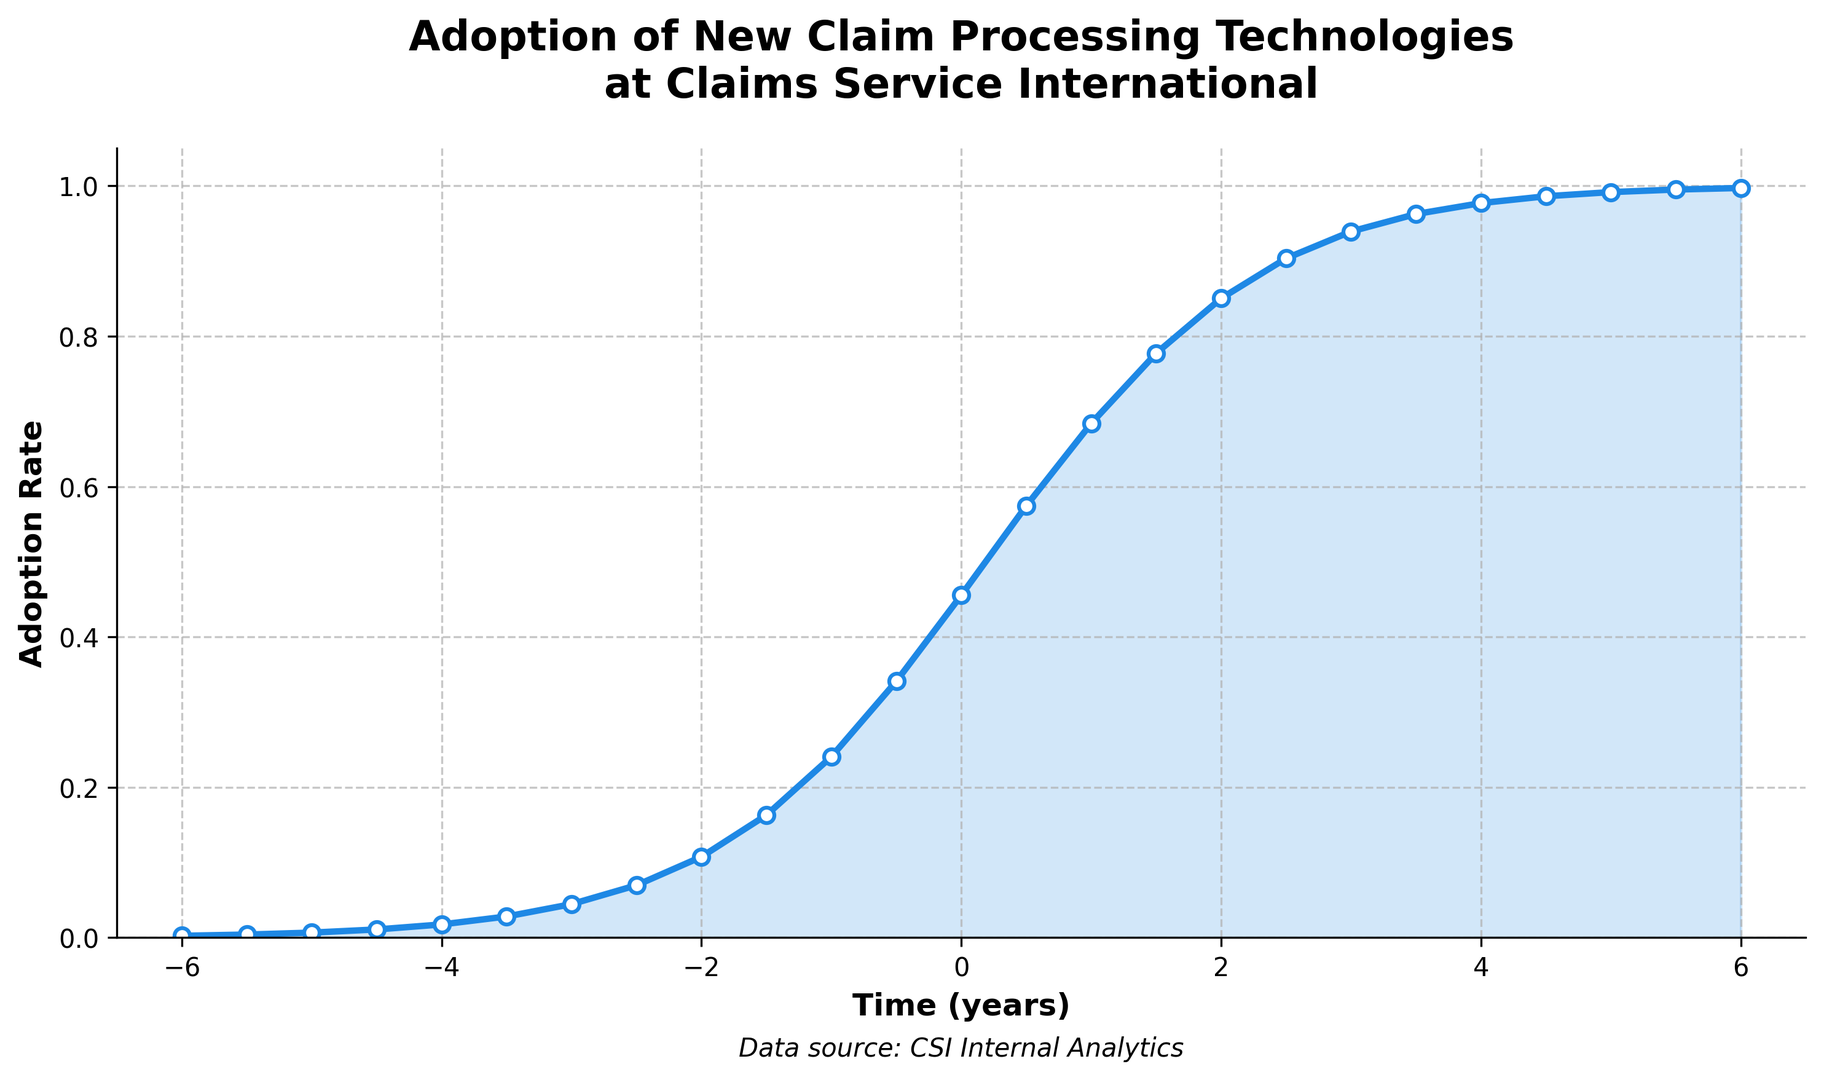When does the adoption rate reach 50%? The adoption rate reaches 50% when the y-value is closest to 0.5. According to the data, this occurs approximately at x = 0.
Answer: 0 What is the adoption rate at time -3 years? To find the adoption rate at time -3 years, locate the value of y corresponding to x = -3 in the data. It is approximately y = 0.044565.
Answer: 0.044565 What is the difference in adoption rates between time -2 years and 2 years? To find the difference, look up the y-values for x = -2 and x = 2. The values are 0.107585 and 0.850457, respectively. Subtract the smaller value from the larger value: 0.850457 - 0.107585 = 0.742872.
Answer: 0.742872 At which time does the adoption rate first exceed 90%? To determine when the adoption rate first exceeds 90%, find the smallest x-value for which y is greater than 0.9. According to the data, this occurs at x = 2.5.
Answer: 2.5 Which time period shows the fastest increase in adoption rate? To find the fastest increase, identify the steepest slope in the y-values over the x values. The rise is fastest between x = -1.5 and x = 0.5, where the adoption rate goes from approximately 0.163058 to 0.574442.
Answer: Between -1.5 and 0.5 What is the general shape of the adoption curve? By examining the plot, it’s clear the adoption curve has an S-shape, typical of a Sigmoid function which indicates slow initial adoption, rapid growth, and then a leveling off.
Answer: S-shape How does the adoption rate at time 5 years compare to time -5 years? Locate the y-values for x = 5 and x = -5 in the data. They are approximately 0.991792 and 0.006693, respectively. The rate at 5 years is significantly higher than at -5 years.
Answer: Higher at 5 years What is the adoption rate 3 years before reaching the inflection point? The inflection point for a sigmoid function occurs at x = 0. Three years before x = 0 is x = -3. The adoption rate at x = -3 is approximately y = 0.044565.
Answer: 0.044565 What portion of the time does the adoption rate spend above 80%? According to the data, y-values start exceeding 80% at x = 2 and maintain above 80% until x = 6. Thus, it spans 4 years.
Answer: 4 years 